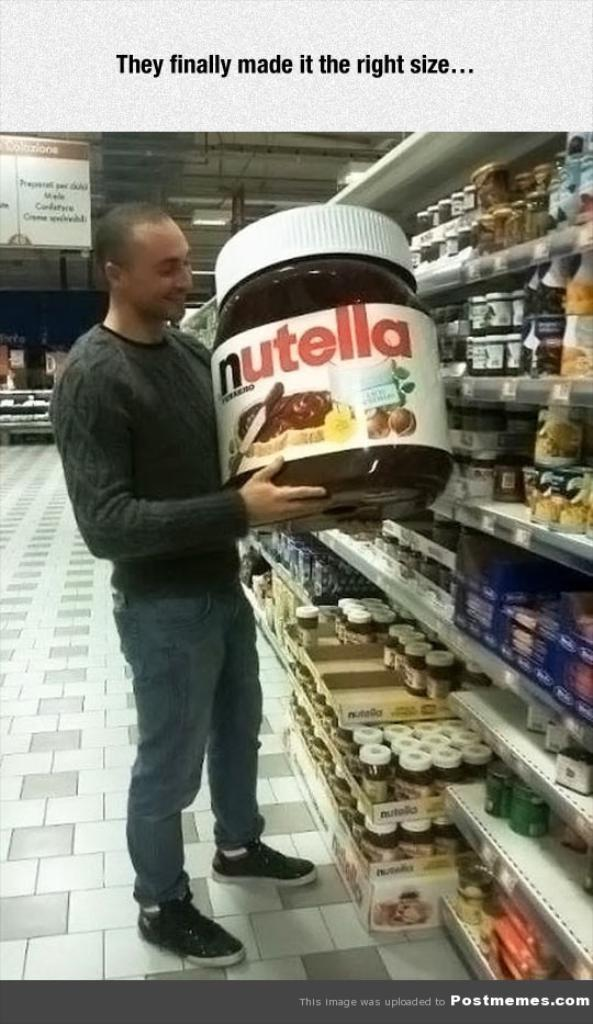<image>
Relay a brief, clear account of the picture shown. a man holds a giant jar of Nutella and looks pleased 